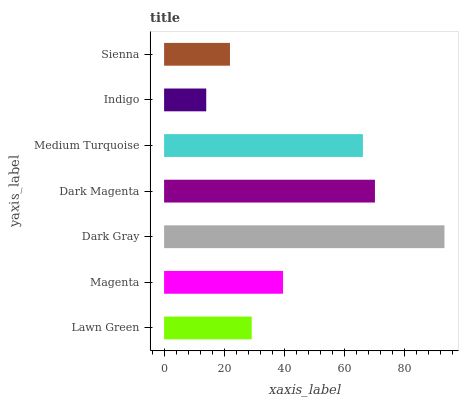Is Indigo the minimum?
Answer yes or no. Yes. Is Dark Gray the maximum?
Answer yes or no. Yes. Is Magenta the minimum?
Answer yes or no. No. Is Magenta the maximum?
Answer yes or no. No. Is Magenta greater than Lawn Green?
Answer yes or no. Yes. Is Lawn Green less than Magenta?
Answer yes or no. Yes. Is Lawn Green greater than Magenta?
Answer yes or no. No. Is Magenta less than Lawn Green?
Answer yes or no. No. Is Magenta the high median?
Answer yes or no. Yes. Is Magenta the low median?
Answer yes or no. Yes. Is Dark Gray the high median?
Answer yes or no. No. Is Dark Magenta the low median?
Answer yes or no. No. 